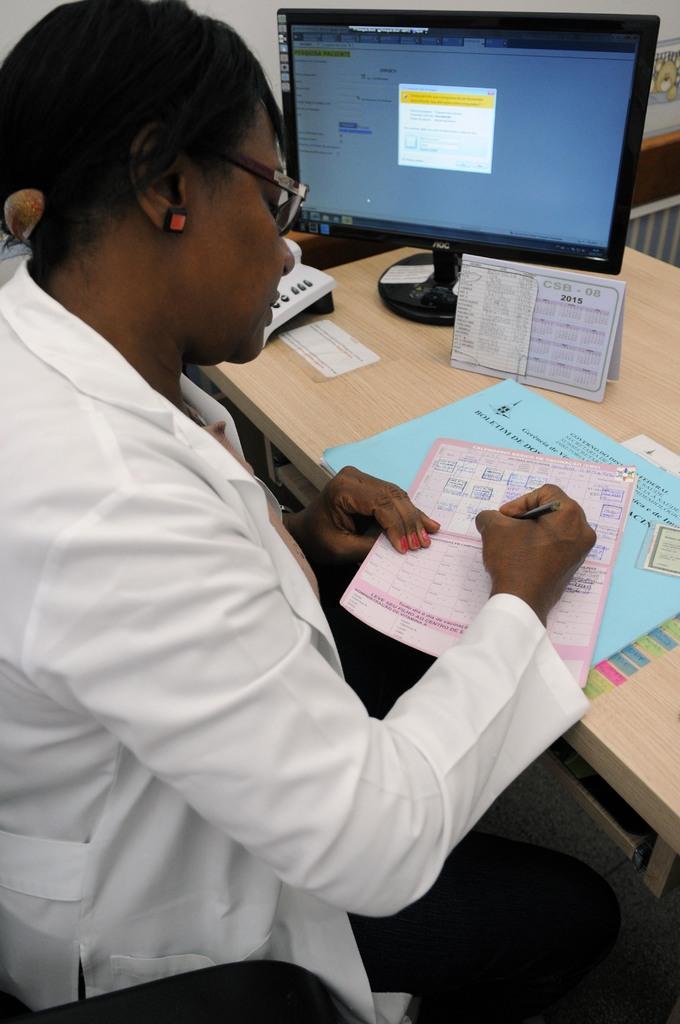What year is this from?
Provide a short and direct response. 2015. 